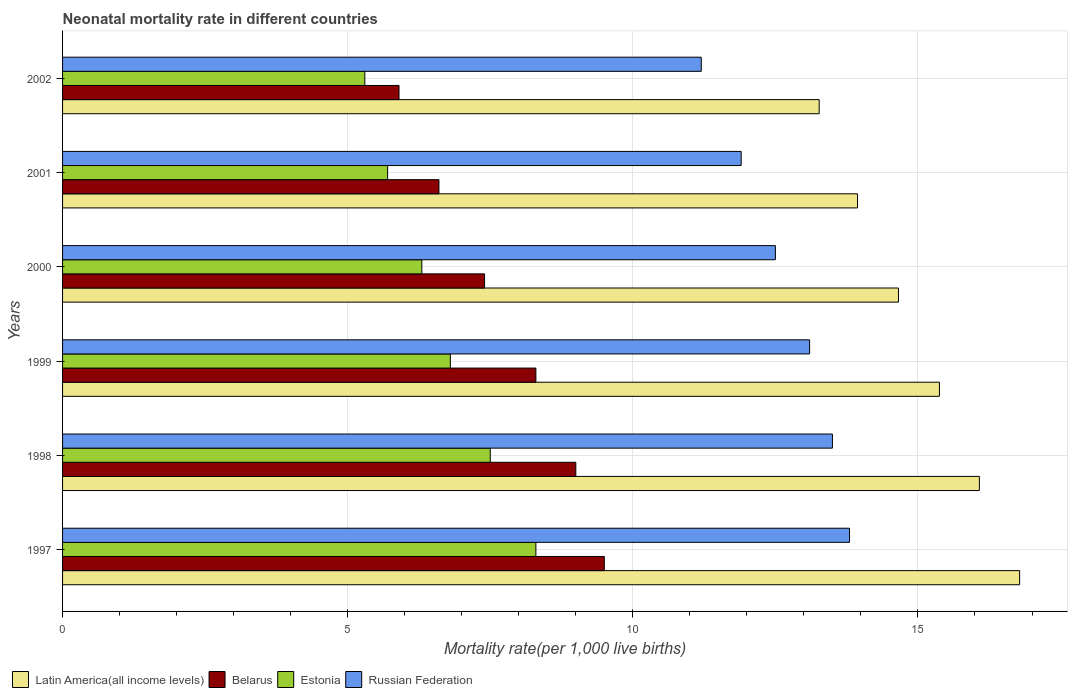How many groups of bars are there?
Make the answer very short. 6. In how many cases, is the number of bars for a given year not equal to the number of legend labels?
Your response must be concise. 0. What is the neonatal mortality rate in Belarus in 2000?
Give a very brief answer. 7.4. Across all years, what is the minimum neonatal mortality rate in Latin America(all income levels)?
Your answer should be very brief. 13.27. In which year was the neonatal mortality rate in Russian Federation maximum?
Provide a succinct answer. 1997. What is the total neonatal mortality rate in Belarus in the graph?
Provide a succinct answer. 46.7. What is the difference between the neonatal mortality rate in Estonia in 1998 and that in 2000?
Your response must be concise. 1.2. What is the difference between the neonatal mortality rate in Belarus in 1998 and the neonatal mortality rate in Latin America(all income levels) in 2002?
Your response must be concise. -4.27. What is the average neonatal mortality rate in Russian Federation per year?
Ensure brevity in your answer.  12.67. In the year 2001, what is the difference between the neonatal mortality rate in Russian Federation and neonatal mortality rate in Latin America(all income levels)?
Offer a terse response. -2.04. In how many years, is the neonatal mortality rate in Russian Federation greater than 11 ?
Offer a very short reply. 6. What is the ratio of the neonatal mortality rate in Belarus in 2000 to that in 2001?
Give a very brief answer. 1.12. Is the neonatal mortality rate in Latin America(all income levels) in 1997 less than that in 2002?
Offer a terse response. No. What is the difference between the highest and the lowest neonatal mortality rate in Russian Federation?
Keep it short and to the point. 2.6. In how many years, is the neonatal mortality rate in Estonia greater than the average neonatal mortality rate in Estonia taken over all years?
Your answer should be compact. 3. Is it the case that in every year, the sum of the neonatal mortality rate in Estonia and neonatal mortality rate in Latin America(all income levels) is greater than the sum of neonatal mortality rate in Russian Federation and neonatal mortality rate in Belarus?
Your answer should be very brief. No. What does the 1st bar from the top in 2000 represents?
Provide a succinct answer. Russian Federation. What does the 4th bar from the bottom in 2002 represents?
Provide a short and direct response. Russian Federation. Is it the case that in every year, the sum of the neonatal mortality rate in Estonia and neonatal mortality rate in Belarus is greater than the neonatal mortality rate in Russian Federation?
Offer a very short reply. No. How many bars are there?
Provide a short and direct response. 24. What is the difference between two consecutive major ticks on the X-axis?
Your answer should be very brief. 5. How are the legend labels stacked?
Ensure brevity in your answer.  Horizontal. What is the title of the graph?
Make the answer very short. Neonatal mortality rate in different countries. What is the label or title of the X-axis?
Provide a succinct answer. Mortality rate(per 1,0 live births). What is the label or title of the Y-axis?
Provide a succinct answer. Years. What is the Mortality rate(per 1,000 live births) in Latin America(all income levels) in 1997?
Provide a succinct answer. 16.78. What is the Mortality rate(per 1,000 live births) in Belarus in 1997?
Offer a terse response. 9.5. What is the Mortality rate(per 1,000 live births) in Estonia in 1997?
Your answer should be compact. 8.3. What is the Mortality rate(per 1,000 live births) of Russian Federation in 1997?
Provide a succinct answer. 13.8. What is the Mortality rate(per 1,000 live births) in Latin America(all income levels) in 1998?
Provide a short and direct response. 16.08. What is the Mortality rate(per 1,000 live births) of Russian Federation in 1998?
Your response must be concise. 13.5. What is the Mortality rate(per 1,000 live births) in Latin America(all income levels) in 1999?
Your answer should be very brief. 15.38. What is the Mortality rate(per 1,000 live births) in Russian Federation in 1999?
Ensure brevity in your answer.  13.1. What is the Mortality rate(per 1,000 live births) in Latin America(all income levels) in 2000?
Make the answer very short. 14.66. What is the Mortality rate(per 1,000 live births) of Belarus in 2000?
Your answer should be compact. 7.4. What is the Mortality rate(per 1,000 live births) of Russian Federation in 2000?
Make the answer very short. 12.5. What is the Mortality rate(per 1,000 live births) of Latin America(all income levels) in 2001?
Give a very brief answer. 13.94. What is the Mortality rate(per 1,000 live births) of Latin America(all income levels) in 2002?
Provide a short and direct response. 13.27. What is the Mortality rate(per 1,000 live births) in Belarus in 2002?
Offer a very short reply. 5.9. What is the Mortality rate(per 1,000 live births) in Estonia in 2002?
Your answer should be very brief. 5.3. What is the Mortality rate(per 1,000 live births) of Russian Federation in 2002?
Your answer should be very brief. 11.2. Across all years, what is the maximum Mortality rate(per 1,000 live births) of Latin America(all income levels)?
Give a very brief answer. 16.78. Across all years, what is the maximum Mortality rate(per 1,000 live births) of Belarus?
Offer a very short reply. 9.5. Across all years, what is the maximum Mortality rate(per 1,000 live births) of Russian Federation?
Ensure brevity in your answer.  13.8. Across all years, what is the minimum Mortality rate(per 1,000 live births) of Latin America(all income levels)?
Offer a very short reply. 13.27. Across all years, what is the minimum Mortality rate(per 1,000 live births) in Belarus?
Offer a very short reply. 5.9. Across all years, what is the minimum Mortality rate(per 1,000 live births) of Estonia?
Ensure brevity in your answer.  5.3. What is the total Mortality rate(per 1,000 live births) of Latin America(all income levels) in the graph?
Your answer should be very brief. 90.1. What is the total Mortality rate(per 1,000 live births) of Belarus in the graph?
Your response must be concise. 46.7. What is the total Mortality rate(per 1,000 live births) in Estonia in the graph?
Your answer should be compact. 39.9. What is the difference between the Mortality rate(per 1,000 live births) of Latin America(all income levels) in 1997 and that in 1998?
Your answer should be compact. 0.71. What is the difference between the Mortality rate(per 1,000 live births) in Latin America(all income levels) in 1997 and that in 1999?
Your answer should be very brief. 1.41. What is the difference between the Mortality rate(per 1,000 live births) in Estonia in 1997 and that in 1999?
Offer a terse response. 1.5. What is the difference between the Mortality rate(per 1,000 live births) in Russian Federation in 1997 and that in 1999?
Your answer should be compact. 0.7. What is the difference between the Mortality rate(per 1,000 live births) of Latin America(all income levels) in 1997 and that in 2000?
Provide a succinct answer. 2.12. What is the difference between the Mortality rate(per 1,000 live births) in Latin America(all income levels) in 1997 and that in 2001?
Keep it short and to the point. 2.84. What is the difference between the Mortality rate(per 1,000 live births) in Belarus in 1997 and that in 2001?
Your answer should be very brief. 2.9. What is the difference between the Mortality rate(per 1,000 live births) of Russian Federation in 1997 and that in 2001?
Offer a very short reply. 1.9. What is the difference between the Mortality rate(per 1,000 live births) in Latin America(all income levels) in 1997 and that in 2002?
Your response must be concise. 3.52. What is the difference between the Mortality rate(per 1,000 live births) in Belarus in 1997 and that in 2002?
Provide a succinct answer. 3.6. What is the difference between the Mortality rate(per 1,000 live births) of Russian Federation in 1997 and that in 2002?
Make the answer very short. 2.6. What is the difference between the Mortality rate(per 1,000 live births) in Latin America(all income levels) in 1998 and that in 1999?
Your answer should be very brief. 0.7. What is the difference between the Mortality rate(per 1,000 live births) in Belarus in 1998 and that in 1999?
Your answer should be very brief. 0.7. What is the difference between the Mortality rate(per 1,000 live births) of Latin America(all income levels) in 1998 and that in 2000?
Offer a terse response. 1.42. What is the difference between the Mortality rate(per 1,000 live births) of Estonia in 1998 and that in 2000?
Your answer should be very brief. 1.2. What is the difference between the Mortality rate(per 1,000 live births) of Latin America(all income levels) in 1998 and that in 2001?
Your answer should be very brief. 2.14. What is the difference between the Mortality rate(per 1,000 live births) of Latin America(all income levels) in 1998 and that in 2002?
Offer a terse response. 2.81. What is the difference between the Mortality rate(per 1,000 live births) in Belarus in 1998 and that in 2002?
Provide a succinct answer. 3.1. What is the difference between the Mortality rate(per 1,000 live births) of Russian Federation in 1998 and that in 2002?
Keep it short and to the point. 2.3. What is the difference between the Mortality rate(per 1,000 live births) in Latin America(all income levels) in 1999 and that in 2000?
Your answer should be very brief. 0.72. What is the difference between the Mortality rate(per 1,000 live births) in Belarus in 1999 and that in 2000?
Keep it short and to the point. 0.9. What is the difference between the Mortality rate(per 1,000 live births) of Russian Federation in 1999 and that in 2000?
Your answer should be very brief. 0.6. What is the difference between the Mortality rate(per 1,000 live births) of Latin America(all income levels) in 1999 and that in 2001?
Provide a succinct answer. 1.44. What is the difference between the Mortality rate(per 1,000 live births) of Estonia in 1999 and that in 2001?
Provide a succinct answer. 1.1. What is the difference between the Mortality rate(per 1,000 live births) of Latin America(all income levels) in 1999 and that in 2002?
Keep it short and to the point. 2.11. What is the difference between the Mortality rate(per 1,000 live births) in Latin America(all income levels) in 2000 and that in 2001?
Your response must be concise. 0.72. What is the difference between the Mortality rate(per 1,000 live births) in Estonia in 2000 and that in 2001?
Ensure brevity in your answer.  0.6. What is the difference between the Mortality rate(per 1,000 live births) in Latin America(all income levels) in 2000 and that in 2002?
Provide a succinct answer. 1.39. What is the difference between the Mortality rate(per 1,000 live births) of Belarus in 2000 and that in 2002?
Offer a very short reply. 1.5. What is the difference between the Mortality rate(per 1,000 live births) in Latin America(all income levels) in 2001 and that in 2002?
Your answer should be compact. 0.67. What is the difference between the Mortality rate(per 1,000 live births) in Latin America(all income levels) in 1997 and the Mortality rate(per 1,000 live births) in Belarus in 1998?
Ensure brevity in your answer.  7.78. What is the difference between the Mortality rate(per 1,000 live births) of Latin America(all income levels) in 1997 and the Mortality rate(per 1,000 live births) of Estonia in 1998?
Give a very brief answer. 9.28. What is the difference between the Mortality rate(per 1,000 live births) in Latin America(all income levels) in 1997 and the Mortality rate(per 1,000 live births) in Russian Federation in 1998?
Offer a very short reply. 3.28. What is the difference between the Mortality rate(per 1,000 live births) in Belarus in 1997 and the Mortality rate(per 1,000 live births) in Estonia in 1998?
Provide a succinct answer. 2. What is the difference between the Mortality rate(per 1,000 live births) of Latin America(all income levels) in 1997 and the Mortality rate(per 1,000 live births) of Belarus in 1999?
Provide a short and direct response. 8.48. What is the difference between the Mortality rate(per 1,000 live births) in Latin America(all income levels) in 1997 and the Mortality rate(per 1,000 live births) in Estonia in 1999?
Your response must be concise. 9.98. What is the difference between the Mortality rate(per 1,000 live births) in Latin America(all income levels) in 1997 and the Mortality rate(per 1,000 live births) in Russian Federation in 1999?
Give a very brief answer. 3.68. What is the difference between the Mortality rate(per 1,000 live births) in Estonia in 1997 and the Mortality rate(per 1,000 live births) in Russian Federation in 1999?
Provide a short and direct response. -4.8. What is the difference between the Mortality rate(per 1,000 live births) in Latin America(all income levels) in 1997 and the Mortality rate(per 1,000 live births) in Belarus in 2000?
Offer a terse response. 9.38. What is the difference between the Mortality rate(per 1,000 live births) in Latin America(all income levels) in 1997 and the Mortality rate(per 1,000 live births) in Estonia in 2000?
Provide a short and direct response. 10.48. What is the difference between the Mortality rate(per 1,000 live births) in Latin America(all income levels) in 1997 and the Mortality rate(per 1,000 live births) in Russian Federation in 2000?
Your response must be concise. 4.28. What is the difference between the Mortality rate(per 1,000 live births) in Estonia in 1997 and the Mortality rate(per 1,000 live births) in Russian Federation in 2000?
Keep it short and to the point. -4.2. What is the difference between the Mortality rate(per 1,000 live births) of Latin America(all income levels) in 1997 and the Mortality rate(per 1,000 live births) of Belarus in 2001?
Give a very brief answer. 10.18. What is the difference between the Mortality rate(per 1,000 live births) of Latin America(all income levels) in 1997 and the Mortality rate(per 1,000 live births) of Estonia in 2001?
Make the answer very short. 11.08. What is the difference between the Mortality rate(per 1,000 live births) in Latin America(all income levels) in 1997 and the Mortality rate(per 1,000 live births) in Russian Federation in 2001?
Give a very brief answer. 4.88. What is the difference between the Mortality rate(per 1,000 live births) in Belarus in 1997 and the Mortality rate(per 1,000 live births) in Russian Federation in 2001?
Keep it short and to the point. -2.4. What is the difference between the Mortality rate(per 1,000 live births) in Estonia in 1997 and the Mortality rate(per 1,000 live births) in Russian Federation in 2001?
Provide a short and direct response. -3.6. What is the difference between the Mortality rate(per 1,000 live births) in Latin America(all income levels) in 1997 and the Mortality rate(per 1,000 live births) in Belarus in 2002?
Offer a very short reply. 10.88. What is the difference between the Mortality rate(per 1,000 live births) in Latin America(all income levels) in 1997 and the Mortality rate(per 1,000 live births) in Estonia in 2002?
Offer a very short reply. 11.48. What is the difference between the Mortality rate(per 1,000 live births) in Latin America(all income levels) in 1997 and the Mortality rate(per 1,000 live births) in Russian Federation in 2002?
Provide a succinct answer. 5.58. What is the difference between the Mortality rate(per 1,000 live births) of Belarus in 1997 and the Mortality rate(per 1,000 live births) of Estonia in 2002?
Your answer should be very brief. 4.2. What is the difference between the Mortality rate(per 1,000 live births) in Belarus in 1997 and the Mortality rate(per 1,000 live births) in Russian Federation in 2002?
Make the answer very short. -1.7. What is the difference between the Mortality rate(per 1,000 live births) of Estonia in 1997 and the Mortality rate(per 1,000 live births) of Russian Federation in 2002?
Keep it short and to the point. -2.9. What is the difference between the Mortality rate(per 1,000 live births) in Latin America(all income levels) in 1998 and the Mortality rate(per 1,000 live births) in Belarus in 1999?
Provide a succinct answer. 7.78. What is the difference between the Mortality rate(per 1,000 live births) in Latin America(all income levels) in 1998 and the Mortality rate(per 1,000 live births) in Estonia in 1999?
Your response must be concise. 9.28. What is the difference between the Mortality rate(per 1,000 live births) in Latin America(all income levels) in 1998 and the Mortality rate(per 1,000 live births) in Russian Federation in 1999?
Offer a terse response. 2.98. What is the difference between the Mortality rate(per 1,000 live births) of Belarus in 1998 and the Mortality rate(per 1,000 live births) of Russian Federation in 1999?
Keep it short and to the point. -4.1. What is the difference between the Mortality rate(per 1,000 live births) of Estonia in 1998 and the Mortality rate(per 1,000 live births) of Russian Federation in 1999?
Your answer should be compact. -5.6. What is the difference between the Mortality rate(per 1,000 live births) of Latin America(all income levels) in 1998 and the Mortality rate(per 1,000 live births) of Belarus in 2000?
Your response must be concise. 8.68. What is the difference between the Mortality rate(per 1,000 live births) of Latin America(all income levels) in 1998 and the Mortality rate(per 1,000 live births) of Estonia in 2000?
Your answer should be very brief. 9.78. What is the difference between the Mortality rate(per 1,000 live births) in Latin America(all income levels) in 1998 and the Mortality rate(per 1,000 live births) in Russian Federation in 2000?
Offer a terse response. 3.58. What is the difference between the Mortality rate(per 1,000 live births) in Estonia in 1998 and the Mortality rate(per 1,000 live births) in Russian Federation in 2000?
Keep it short and to the point. -5. What is the difference between the Mortality rate(per 1,000 live births) of Latin America(all income levels) in 1998 and the Mortality rate(per 1,000 live births) of Belarus in 2001?
Offer a terse response. 9.48. What is the difference between the Mortality rate(per 1,000 live births) in Latin America(all income levels) in 1998 and the Mortality rate(per 1,000 live births) in Estonia in 2001?
Ensure brevity in your answer.  10.38. What is the difference between the Mortality rate(per 1,000 live births) of Latin America(all income levels) in 1998 and the Mortality rate(per 1,000 live births) of Russian Federation in 2001?
Provide a short and direct response. 4.18. What is the difference between the Mortality rate(per 1,000 live births) of Belarus in 1998 and the Mortality rate(per 1,000 live births) of Estonia in 2001?
Provide a succinct answer. 3.3. What is the difference between the Mortality rate(per 1,000 live births) of Belarus in 1998 and the Mortality rate(per 1,000 live births) of Russian Federation in 2001?
Your answer should be compact. -2.9. What is the difference between the Mortality rate(per 1,000 live births) of Latin America(all income levels) in 1998 and the Mortality rate(per 1,000 live births) of Belarus in 2002?
Give a very brief answer. 10.18. What is the difference between the Mortality rate(per 1,000 live births) of Latin America(all income levels) in 1998 and the Mortality rate(per 1,000 live births) of Estonia in 2002?
Keep it short and to the point. 10.78. What is the difference between the Mortality rate(per 1,000 live births) in Latin America(all income levels) in 1998 and the Mortality rate(per 1,000 live births) in Russian Federation in 2002?
Your response must be concise. 4.88. What is the difference between the Mortality rate(per 1,000 live births) in Belarus in 1998 and the Mortality rate(per 1,000 live births) in Estonia in 2002?
Make the answer very short. 3.7. What is the difference between the Mortality rate(per 1,000 live births) in Belarus in 1998 and the Mortality rate(per 1,000 live births) in Russian Federation in 2002?
Your response must be concise. -2.2. What is the difference between the Mortality rate(per 1,000 live births) in Latin America(all income levels) in 1999 and the Mortality rate(per 1,000 live births) in Belarus in 2000?
Give a very brief answer. 7.98. What is the difference between the Mortality rate(per 1,000 live births) of Latin America(all income levels) in 1999 and the Mortality rate(per 1,000 live births) of Estonia in 2000?
Give a very brief answer. 9.08. What is the difference between the Mortality rate(per 1,000 live births) in Latin America(all income levels) in 1999 and the Mortality rate(per 1,000 live births) in Russian Federation in 2000?
Make the answer very short. 2.88. What is the difference between the Mortality rate(per 1,000 live births) in Estonia in 1999 and the Mortality rate(per 1,000 live births) in Russian Federation in 2000?
Make the answer very short. -5.7. What is the difference between the Mortality rate(per 1,000 live births) of Latin America(all income levels) in 1999 and the Mortality rate(per 1,000 live births) of Belarus in 2001?
Offer a very short reply. 8.78. What is the difference between the Mortality rate(per 1,000 live births) in Latin America(all income levels) in 1999 and the Mortality rate(per 1,000 live births) in Estonia in 2001?
Provide a succinct answer. 9.68. What is the difference between the Mortality rate(per 1,000 live births) of Latin America(all income levels) in 1999 and the Mortality rate(per 1,000 live births) of Russian Federation in 2001?
Offer a very short reply. 3.48. What is the difference between the Mortality rate(per 1,000 live births) in Belarus in 1999 and the Mortality rate(per 1,000 live births) in Estonia in 2001?
Give a very brief answer. 2.6. What is the difference between the Mortality rate(per 1,000 live births) in Belarus in 1999 and the Mortality rate(per 1,000 live births) in Russian Federation in 2001?
Provide a short and direct response. -3.6. What is the difference between the Mortality rate(per 1,000 live births) in Latin America(all income levels) in 1999 and the Mortality rate(per 1,000 live births) in Belarus in 2002?
Your answer should be compact. 9.48. What is the difference between the Mortality rate(per 1,000 live births) of Latin America(all income levels) in 1999 and the Mortality rate(per 1,000 live births) of Estonia in 2002?
Offer a terse response. 10.08. What is the difference between the Mortality rate(per 1,000 live births) in Latin America(all income levels) in 1999 and the Mortality rate(per 1,000 live births) in Russian Federation in 2002?
Provide a short and direct response. 4.18. What is the difference between the Mortality rate(per 1,000 live births) of Belarus in 1999 and the Mortality rate(per 1,000 live births) of Russian Federation in 2002?
Your answer should be very brief. -2.9. What is the difference between the Mortality rate(per 1,000 live births) of Estonia in 1999 and the Mortality rate(per 1,000 live births) of Russian Federation in 2002?
Make the answer very short. -4.4. What is the difference between the Mortality rate(per 1,000 live births) of Latin America(all income levels) in 2000 and the Mortality rate(per 1,000 live births) of Belarus in 2001?
Your answer should be compact. 8.06. What is the difference between the Mortality rate(per 1,000 live births) in Latin America(all income levels) in 2000 and the Mortality rate(per 1,000 live births) in Estonia in 2001?
Give a very brief answer. 8.96. What is the difference between the Mortality rate(per 1,000 live births) in Latin America(all income levels) in 2000 and the Mortality rate(per 1,000 live births) in Russian Federation in 2001?
Your answer should be very brief. 2.76. What is the difference between the Mortality rate(per 1,000 live births) of Belarus in 2000 and the Mortality rate(per 1,000 live births) of Estonia in 2001?
Ensure brevity in your answer.  1.7. What is the difference between the Mortality rate(per 1,000 live births) of Belarus in 2000 and the Mortality rate(per 1,000 live births) of Russian Federation in 2001?
Give a very brief answer. -4.5. What is the difference between the Mortality rate(per 1,000 live births) of Estonia in 2000 and the Mortality rate(per 1,000 live births) of Russian Federation in 2001?
Provide a short and direct response. -5.6. What is the difference between the Mortality rate(per 1,000 live births) in Latin America(all income levels) in 2000 and the Mortality rate(per 1,000 live births) in Belarus in 2002?
Offer a very short reply. 8.76. What is the difference between the Mortality rate(per 1,000 live births) in Latin America(all income levels) in 2000 and the Mortality rate(per 1,000 live births) in Estonia in 2002?
Offer a very short reply. 9.36. What is the difference between the Mortality rate(per 1,000 live births) in Latin America(all income levels) in 2000 and the Mortality rate(per 1,000 live births) in Russian Federation in 2002?
Offer a terse response. 3.46. What is the difference between the Mortality rate(per 1,000 live births) in Belarus in 2000 and the Mortality rate(per 1,000 live births) in Estonia in 2002?
Give a very brief answer. 2.1. What is the difference between the Mortality rate(per 1,000 live births) in Belarus in 2000 and the Mortality rate(per 1,000 live births) in Russian Federation in 2002?
Your answer should be very brief. -3.8. What is the difference between the Mortality rate(per 1,000 live births) in Estonia in 2000 and the Mortality rate(per 1,000 live births) in Russian Federation in 2002?
Provide a short and direct response. -4.9. What is the difference between the Mortality rate(per 1,000 live births) in Latin America(all income levels) in 2001 and the Mortality rate(per 1,000 live births) in Belarus in 2002?
Ensure brevity in your answer.  8.04. What is the difference between the Mortality rate(per 1,000 live births) of Latin America(all income levels) in 2001 and the Mortality rate(per 1,000 live births) of Estonia in 2002?
Provide a succinct answer. 8.64. What is the difference between the Mortality rate(per 1,000 live births) in Latin America(all income levels) in 2001 and the Mortality rate(per 1,000 live births) in Russian Federation in 2002?
Ensure brevity in your answer.  2.74. What is the difference between the Mortality rate(per 1,000 live births) of Belarus in 2001 and the Mortality rate(per 1,000 live births) of Russian Federation in 2002?
Provide a short and direct response. -4.6. What is the average Mortality rate(per 1,000 live births) of Latin America(all income levels) per year?
Provide a succinct answer. 15.02. What is the average Mortality rate(per 1,000 live births) of Belarus per year?
Keep it short and to the point. 7.78. What is the average Mortality rate(per 1,000 live births) of Estonia per year?
Your response must be concise. 6.65. What is the average Mortality rate(per 1,000 live births) in Russian Federation per year?
Your response must be concise. 12.67. In the year 1997, what is the difference between the Mortality rate(per 1,000 live births) in Latin America(all income levels) and Mortality rate(per 1,000 live births) in Belarus?
Your response must be concise. 7.28. In the year 1997, what is the difference between the Mortality rate(per 1,000 live births) in Latin America(all income levels) and Mortality rate(per 1,000 live births) in Estonia?
Offer a very short reply. 8.48. In the year 1997, what is the difference between the Mortality rate(per 1,000 live births) in Latin America(all income levels) and Mortality rate(per 1,000 live births) in Russian Federation?
Keep it short and to the point. 2.98. In the year 1997, what is the difference between the Mortality rate(per 1,000 live births) of Belarus and Mortality rate(per 1,000 live births) of Russian Federation?
Ensure brevity in your answer.  -4.3. In the year 1997, what is the difference between the Mortality rate(per 1,000 live births) in Estonia and Mortality rate(per 1,000 live births) in Russian Federation?
Offer a terse response. -5.5. In the year 1998, what is the difference between the Mortality rate(per 1,000 live births) in Latin America(all income levels) and Mortality rate(per 1,000 live births) in Belarus?
Your answer should be very brief. 7.08. In the year 1998, what is the difference between the Mortality rate(per 1,000 live births) in Latin America(all income levels) and Mortality rate(per 1,000 live births) in Estonia?
Your answer should be very brief. 8.58. In the year 1998, what is the difference between the Mortality rate(per 1,000 live births) in Latin America(all income levels) and Mortality rate(per 1,000 live births) in Russian Federation?
Your response must be concise. 2.58. In the year 1998, what is the difference between the Mortality rate(per 1,000 live births) of Belarus and Mortality rate(per 1,000 live births) of Estonia?
Offer a terse response. 1.5. In the year 1998, what is the difference between the Mortality rate(per 1,000 live births) of Estonia and Mortality rate(per 1,000 live births) of Russian Federation?
Offer a terse response. -6. In the year 1999, what is the difference between the Mortality rate(per 1,000 live births) of Latin America(all income levels) and Mortality rate(per 1,000 live births) of Belarus?
Your answer should be very brief. 7.08. In the year 1999, what is the difference between the Mortality rate(per 1,000 live births) in Latin America(all income levels) and Mortality rate(per 1,000 live births) in Estonia?
Offer a very short reply. 8.58. In the year 1999, what is the difference between the Mortality rate(per 1,000 live births) in Latin America(all income levels) and Mortality rate(per 1,000 live births) in Russian Federation?
Provide a succinct answer. 2.28. In the year 1999, what is the difference between the Mortality rate(per 1,000 live births) in Belarus and Mortality rate(per 1,000 live births) in Estonia?
Ensure brevity in your answer.  1.5. In the year 2000, what is the difference between the Mortality rate(per 1,000 live births) in Latin America(all income levels) and Mortality rate(per 1,000 live births) in Belarus?
Your answer should be compact. 7.26. In the year 2000, what is the difference between the Mortality rate(per 1,000 live births) of Latin America(all income levels) and Mortality rate(per 1,000 live births) of Estonia?
Your answer should be very brief. 8.36. In the year 2000, what is the difference between the Mortality rate(per 1,000 live births) in Latin America(all income levels) and Mortality rate(per 1,000 live births) in Russian Federation?
Keep it short and to the point. 2.16. In the year 2000, what is the difference between the Mortality rate(per 1,000 live births) in Belarus and Mortality rate(per 1,000 live births) in Estonia?
Your answer should be very brief. 1.1. In the year 2001, what is the difference between the Mortality rate(per 1,000 live births) in Latin America(all income levels) and Mortality rate(per 1,000 live births) in Belarus?
Offer a very short reply. 7.34. In the year 2001, what is the difference between the Mortality rate(per 1,000 live births) in Latin America(all income levels) and Mortality rate(per 1,000 live births) in Estonia?
Your answer should be very brief. 8.24. In the year 2001, what is the difference between the Mortality rate(per 1,000 live births) of Latin America(all income levels) and Mortality rate(per 1,000 live births) of Russian Federation?
Ensure brevity in your answer.  2.04. In the year 2001, what is the difference between the Mortality rate(per 1,000 live births) in Belarus and Mortality rate(per 1,000 live births) in Russian Federation?
Keep it short and to the point. -5.3. In the year 2001, what is the difference between the Mortality rate(per 1,000 live births) of Estonia and Mortality rate(per 1,000 live births) of Russian Federation?
Provide a short and direct response. -6.2. In the year 2002, what is the difference between the Mortality rate(per 1,000 live births) of Latin America(all income levels) and Mortality rate(per 1,000 live births) of Belarus?
Keep it short and to the point. 7.37. In the year 2002, what is the difference between the Mortality rate(per 1,000 live births) of Latin America(all income levels) and Mortality rate(per 1,000 live births) of Estonia?
Make the answer very short. 7.97. In the year 2002, what is the difference between the Mortality rate(per 1,000 live births) in Latin America(all income levels) and Mortality rate(per 1,000 live births) in Russian Federation?
Your response must be concise. 2.07. In the year 2002, what is the difference between the Mortality rate(per 1,000 live births) in Belarus and Mortality rate(per 1,000 live births) in Estonia?
Your answer should be compact. 0.6. In the year 2002, what is the difference between the Mortality rate(per 1,000 live births) of Estonia and Mortality rate(per 1,000 live births) of Russian Federation?
Offer a very short reply. -5.9. What is the ratio of the Mortality rate(per 1,000 live births) of Latin America(all income levels) in 1997 to that in 1998?
Offer a very short reply. 1.04. What is the ratio of the Mortality rate(per 1,000 live births) in Belarus in 1997 to that in 1998?
Ensure brevity in your answer.  1.06. What is the ratio of the Mortality rate(per 1,000 live births) in Estonia in 1997 to that in 1998?
Provide a short and direct response. 1.11. What is the ratio of the Mortality rate(per 1,000 live births) of Russian Federation in 1997 to that in 1998?
Offer a very short reply. 1.02. What is the ratio of the Mortality rate(per 1,000 live births) of Latin America(all income levels) in 1997 to that in 1999?
Keep it short and to the point. 1.09. What is the ratio of the Mortality rate(per 1,000 live births) of Belarus in 1997 to that in 1999?
Keep it short and to the point. 1.14. What is the ratio of the Mortality rate(per 1,000 live births) in Estonia in 1997 to that in 1999?
Offer a very short reply. 1.22. What is the ratio of the Mortality rate(per 1,000 live births) in Russian Federation in 1997 to that in 1999?
Provide a succinct answer. 1.05. What is the ratio of the Mortality rate(per 1,000 live births) in Latin America(all income levels) in 1997 to that in 2000?
Your answer should be compact. 1.14. What is the ratio of the Mortality rate(per 1,000 live births) of Belarus in 1997 to that in 2000?
Provide a succinct answer. 1.28. What is the ratio of the Mortality rate(per 1,000 live births) of Estonia in 1997 to that in 2000?
Provide a succinct answer. 1.32. What is the ratio of the Mortality rate(per 1,000 live births) of Russian Federation in 1997 to that in 2000?
Your response must be concise. 1.1. What is the ratio of the Mortality rate(per 1,000 live births) in Latin America(all income levels) in 1997 to that in 2001?
Offer a very short reply. 1.2. What is the ratio of the Mortality rate(per 1,000 live births) in Belarus in 1997 to that in 2001?
Keep it short and to the point. 1.44. What is the ratio of the Mortality rate(per 1,000 live births) in Estonia in 1997 to that in 2001?
Provide a short and direct response. 1.46. What is the ratio of the Mortality rate(per 1,000 live births) of Russian Federation in 1997 to that in 2001?
Your answer should be compact. 1.16. What is the ratio of the Mortality rate(per 1,000 live births) in Latin America(all income levels) in 1997 to that in 2002?
Offer a terse response. 1.26. What is the ratio of the Mortality rate(per 1,000 live births) in Belarus in 1997 to that in 2002?
Offer a terse response. 1.61. What is the ratio of the Mortality rate(per 1,000 live births) of Estonia in 1997 to that in 2002?
Provide a succinct answer. 1.57. What is the ratio of the Mortality rate(per 1,000 live births) of Russian Federation in 1997 to that in 2002?
Provide a short and direct response. 1.23. What is the ratio of the Mortality rate(per 1,000 live births) in Latin America(all income levels) in 1998 to that in 1999?
Keep it short and to the point. 1.05. What is the ratio of the Mortality rate(per 1,000 live births) in Belarus in 1998 to that in 1999?
Offer a terse response. 1.08. What is the ratio of the Mortality rate(per 1,000 live births) in Estonia in 1998 to that in 1999?
Offer a terse response. 1.1. What is the ratio of the Mortality rate(per 1,000 live births) of Russian Federation in 1998 to that in 1999?
Your answer should be very brief. 1.03. What is the ratio of the Mortality rate(per 1,000 live births) of Latin America(all income levels) in 1998 to that in 2000?
Offer a terse response. 1.1. What is the ratio of the Mortality rate(per 1,000 live births) in Belarus in 1998 to that in 2000?
Provide a short and direct response. 1.22. What is the ratio of the Mortality rate(per 1,000 live births) of Estonia in 1998 to that in 2000?
Provide a succinct answer. 1.19. What is the ratio of the Mortality rate(per 1,000 live births) in Russian Federation in 1998 to that in 2000?
Provide a succinct answer. 1.08. What is the ratio of the Mortality rate(per 1,000 live births) of Latin America(all income levels) in 1998 to that in 2001?
Ensure brevity in your answer.  1.15. What is the ratio of the Mortality rate(per 1,000 live births) of Belarus in 1998 to that in 2001?
Your answer should be compact. 1.36. What is the ratio of the Mortality rate(per 1,000 live births) in Estonia in 1998 to that in 2001?
Your response must be concise. 1.32. What is the ratio of the Mortality rate(per 1,000 live births) in Russian Federation in 1998 to that in 2001?
Offer a terse response. 1.13. What is the ratio of the Mortality rate(per 1,000 live births) in Latin America(all income levels) in 1998 to that in 2002?
Make the answer very short. 1.21. What is the ratio of the Mortality rate(per 1,000 live births) in Belarus in 1998 to that in 2002?
Keep it short and to the point. 1.53. What is the ratio of the Mortality rate(per 1,000 live births) of Estonia in 1998 to that in 2002?
Your answer should be compact. 1.42. What is the ratio of the Mortality rate(per 1,000 live births) in Russian Federation in 1998 to that in 2002?
Offer a very short reply. 1.21. What is the ratio of the Mortality rate(per 1,000 live births) in Latin America(all income levels) in 1999 to that in 2000?
Provide a short and direct response. 1.05. What is the ratio of the Mortality rate(per 1,000 live births) in Belarus in 1999 to that in 2000?
Provide a short and direct response. 1.12. What is the ratio of the Mortality rate(per 1,000 live births) of Estonia in 1999 to that in 2000?
Your answer should be very brief. 1.08. What is the ratio of the Mortality rate(per 1,000 live births) of Russian Federation in 1999 to that in 2000?
Your answer should be compact. 1.05. What is the ratio of the Mortality rate(per 1,000 live births) of Latin America(all income levels) in 1999 to that in 2001?
Your answer should be very brief. 1.1. What is the ratio of the Mortality rate(per 1,000 live births) in Belarus in 1999 to that in 2001?
Provide a short and direct response. 1.26. What is the ratio of the Mortality rate(per 1,000 live births) of Estonia in 1999 to that in 2001?
Your response must be concise. 1.19. What is the ratio of the Mortality rate(per 1,000 live births) in Russian Federation in 1999 to that in 2001?
Ensure brevity in your answer.  1.1. What is the ratio of the Mortality rate(per 1,000 live births) of Latin America(all income levels) in 1999 to that in 2002?
Your answer should be very brief. 1.16. What is the ratio of the Mortality rate(per 1,000 live births) in Belarus in 1999 to that in 2002?
Ensure brevity in your answer.  1.41. What is the ratio of the Mortality rate(per 1,000 live births) of Estonia in 1999 to that in 2002?
Your answer should be very brief. 1.28. What is the ratio of the Mortality rate(per 1,000 live births) in Russian Federation in 1999 to that in 2002?
Make the answer very short. 1.17. What is the ratio of the Mortality rate(per 1,000 live births) of Latin America(all income levels) in 2000 to that in 2001?
Make the answer very short. 1.05. What is the ratio of the Mortality rate(per 1,000 live births) of Belarus in 2000 to that in 2001?
Make the answer very short. 1.12. What is the ratio of the Mortality rate(per 1,000 live births) in Estonia in 2000 to that in 2001?
Provide a short and direct response. 1.11. What is the ratio of the Mortality rate(per 1,000 live births) in Russian Federation in 2000 to that in 2001?
Your answer should be compact. 1.05. What is the ratio of the Mortality rate(per 1,000 live births) of Latin America(all income levels) in 2000 to that in 2002?
Give a very brief answer. 1.1. What is the ratio of the Mortality rate(per 1,000 live births) in Belarus in 2000 to that in 2002?
Provide a succinct answer. 1.25. What is the ratio of the Mortality rate(per 1,000 live births) in Estonia in 2000 to that in 2002?
Offer a very short reply. 1.19. What is the ratio of the Mortality rate(per 1,000 live births) in Russian Federation in 2000 to that in 2002?
Your answer should be compact. 1.12. What is the ratio of the Mortality rate(per 1,000 live births) of Latin America(all income levels) in 2001 to that in 2002?
Ensure brevity in your answer.  1.05. What is the ratio of the Mortality rate(per 1,000 live births) in Belarus in 2001 to that in 2002?
Give a very brief answer. 1.12. What is the ratio of the Mortality rate(per 1,000 live births) of Estonia in 2001 to that in 2002?
Provide a succinct answer. 1.08. What is the difference between the highest and the second highest Mortality rate(per 1,000 live births) in Latin America(all income levels)?
Your response must be concise. 0.71. What is the difference between the highest and the second highest Mortality rate(per 1,000 live births) of Belarus?
Your response must be concise. 0.5. What is the difference between the highest and the lowest Mortality rate(per 1,000 live births) in Latin America(all income levels)?
Offer a terse response. 3.52. What is the difference between the highest and the lowest Mortality rate(per 1,000 live births) of Belarus?
Make the answer very short. 3.6. What is the difference between the highest and the lowest Mortality rate(per 1,000 live births) of Estonia?
Your answer should be compact. 3. 